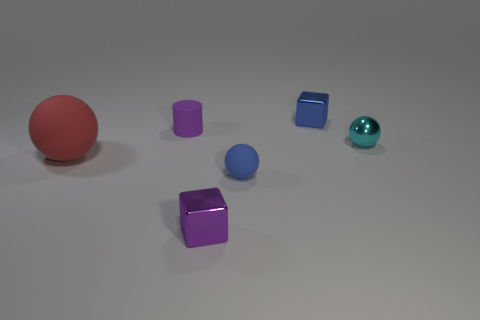Are there an equal number of tiny objects that are in front of the small cyan metal object and large gray matte things?
Provide a succinct answer. No. The shiny thing that is the same color as the cylinder is what size?
Give a very brief answer. Small. Are there any cubes made of the same material as the red sphere?
Provide a short and direct response. No. Is the shape of the blue thing that is on the right side of the tiny blue rubber sphere the same as the small thing that is on the right side of the small blue shiny thing?
Your answer should be very brief. No. Are there any large red matte balls?
Keep it short and to the point. Yes. There is a matte thing that is the same size as the purple rubber cylinder; what color is it?
Make the answer very short. Blue. What number of small metal objects are the same shape as the large red thing?
Your answer should be compact. 1. Is the material of the small blue object behind the large red rubber object the same as the red ball?
Your answer should be very brief. No. What number of spheres are either big things or small shiny things?
Make the answer very short. 2. What shape is the metallic thing left of the shiny block that is on the right side of the tiny rubber object in front of the cyan metal thing?
Provide a succinct answer. Cube. 